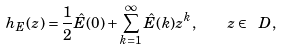<formula> <loc_0><loc_0><loc_500><loc_500>h _ { E } ( z ) = \frac { 1 } { 2 } \hat { E } ( 0 ) + \sum _ { k = 1 } ^ { \infty } \hat { E } ( k ) z ^ { k } , \quad z \in \ D ,</formula> 